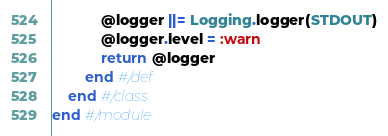Convert code to text. <code><loc_0><loc_0><loc_500><loc_500><_Ruby_>			@logger ||= Logging.logger(STDOUT)
			@logger.level = :warn
			return @logger
		end #/def
	end #/class
end #/module</code> 